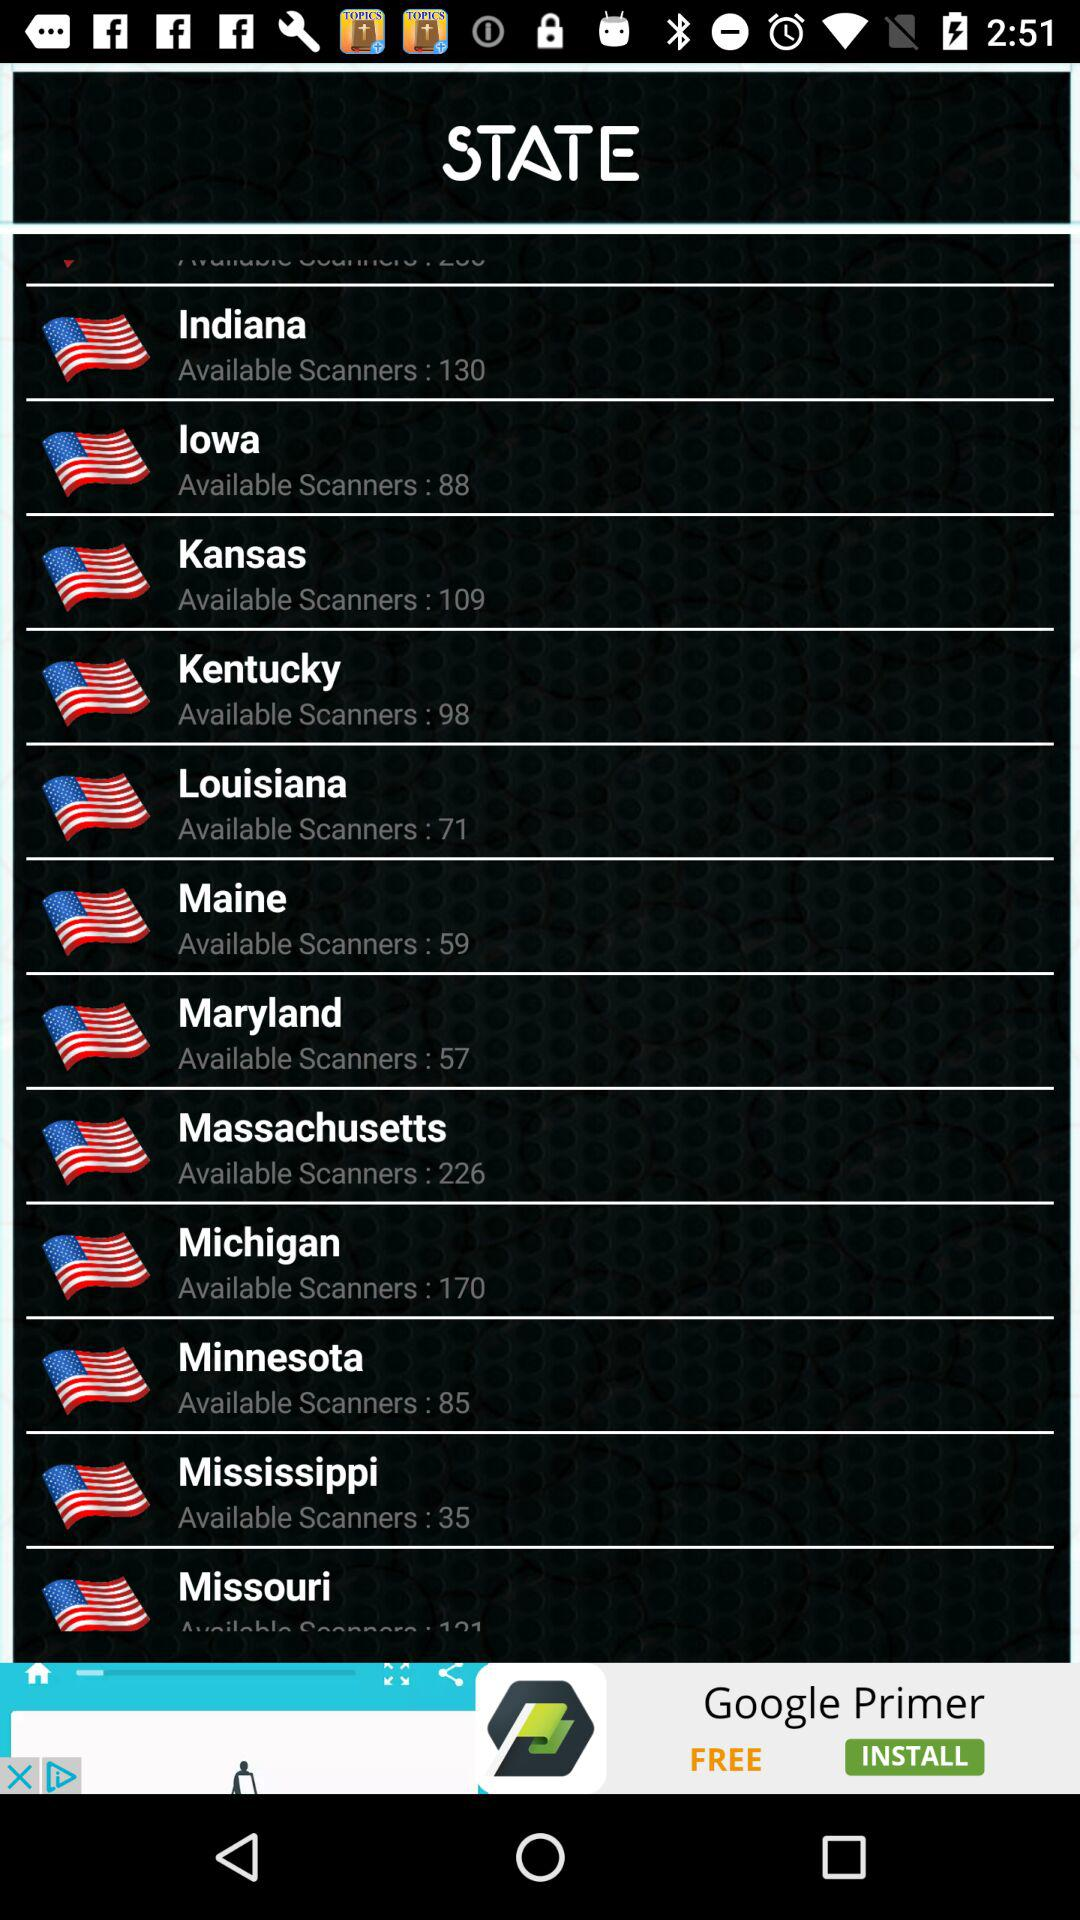How many scanners are there in Maine? There are 59 scanners. 